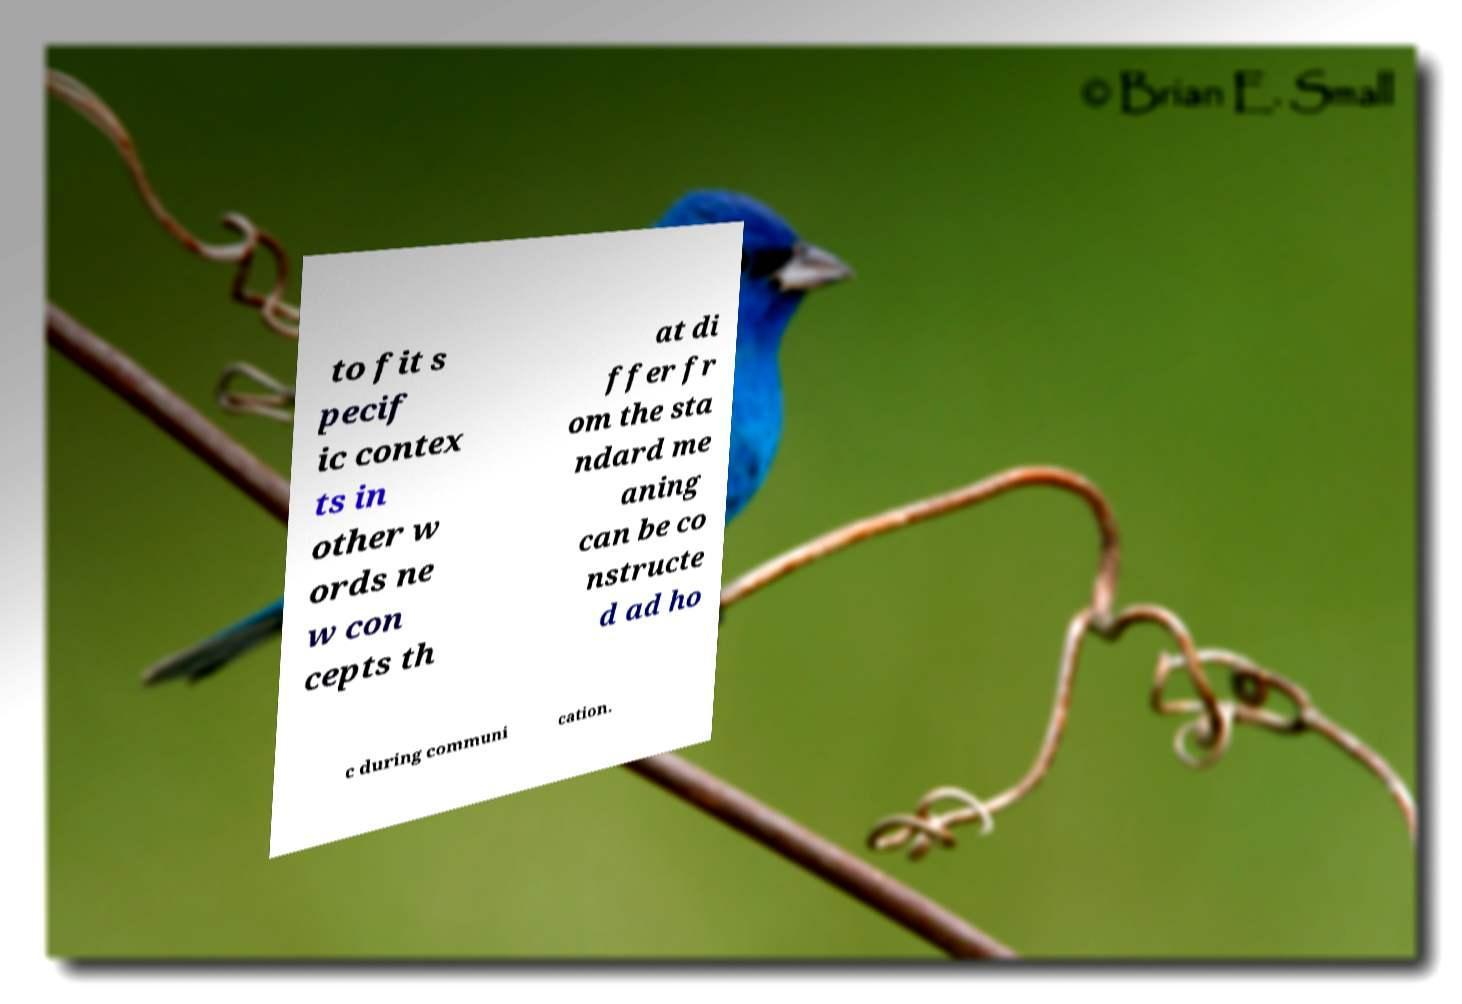Could you extract and type out the text from this image? to fit s pecif ic contex ts in other w ords ne w con cepts th at di ffer fr om the sta ndard me aning can be co nstructe d ad ho c during communi cation. 